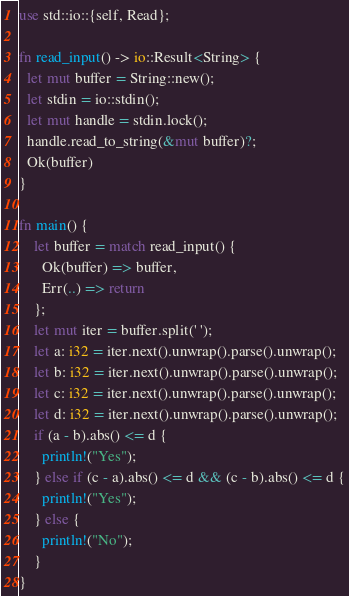<code> <loc_0><loc_0><loc_500><loc_500><_Rust_>use std::io::{self, Read};

fn read_input() -> io::Result<String> {
  let mut buffer = String::new();
  let stdin = io::stdin();
  let mut handle = stdin.lock();
  handle.read_to_string(&mut buffer)?;
  Ok(buffer)
}

fn main() {
    let buffer = match read_input() {
      Ok(buffer) => buffer,
      Err(..) => return
    };
    let mut iter = buffer.split(' ');
    let a: i32 = iter.next().unwrap().parse().unwrap();
    let b: i32 = iter.next().unwrap().parse().unwrap();
    let c: i32 = iter.next().unwrap().parse().unwrap();
    let d: i32 = iter.next().unwrap().parse().unwrap();
    if (a - b).abs() <= d {
      println!("Yes");
    } else if (c - a).abs() <= d && (c - b).abs() <= d {
      println!("Yes");
    } else {
      println!("No");
    }
}</code> 